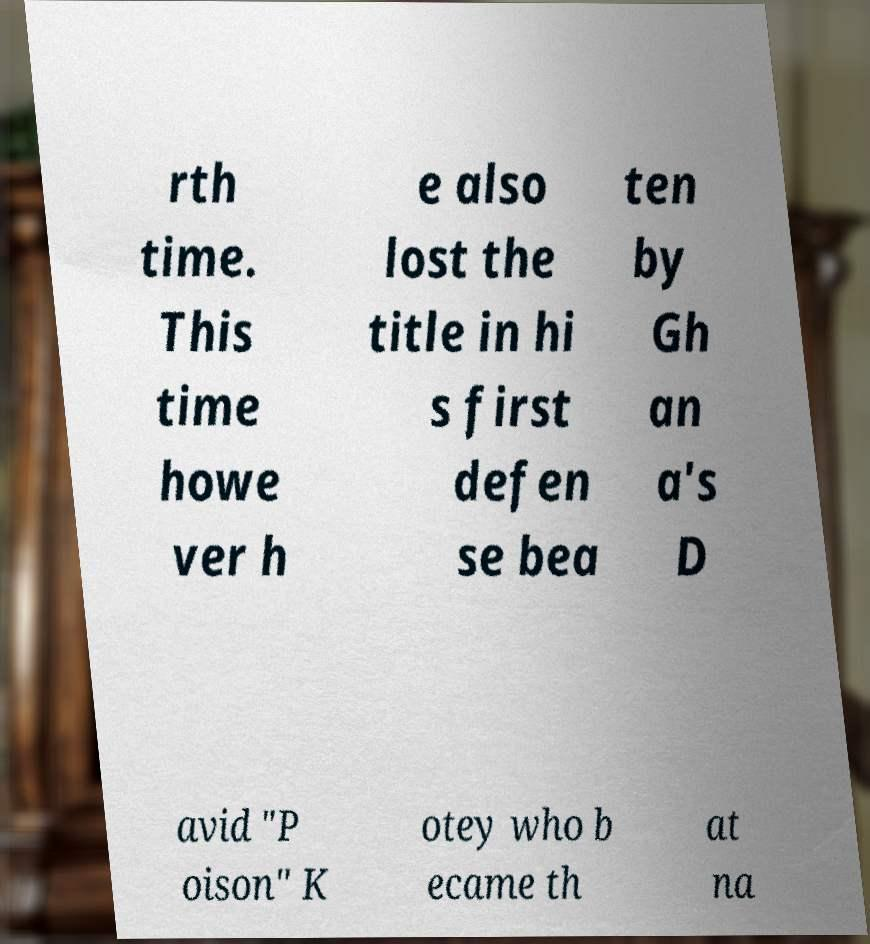I need the written content from this picture converted into text. Can you do that? rth time. This time howe ver h e also lost the title in hi s first defen se bea ten by Gh an a's D avid "P oison" K otey who b ecame th at na 